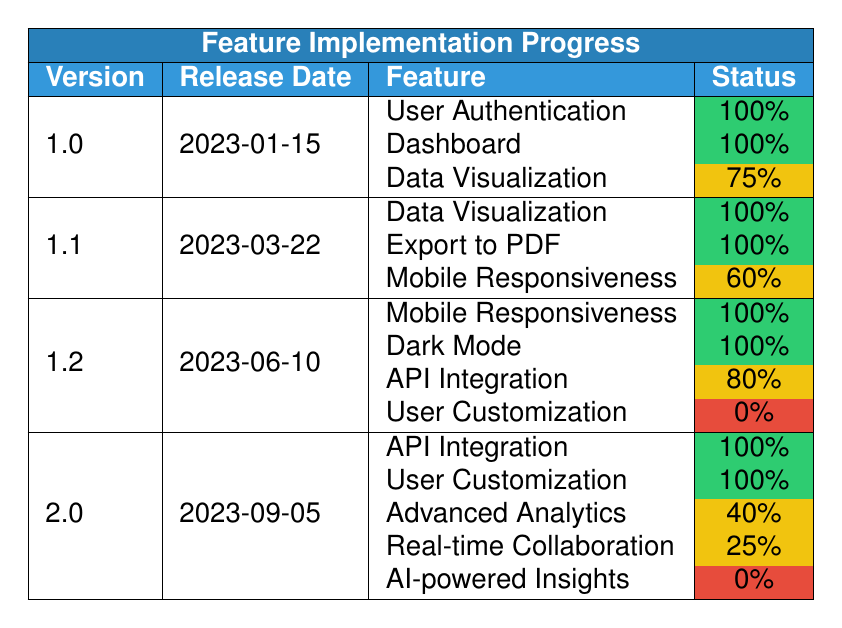What features were completed in version 1.1? In version 1.1, the features listed are Data Visualization (100%), Export to PDF (100%), and Mobile Responsiveness (60%). The completed features are Data Visualization and Export to PDF.
Answer: Data Visualization, Export to PDF What is the completion percentage of the feature "Advanced Analytics" in version 2.0? The feature "Advanced Analytics" in version 2.0 has a completion percentage of 40%, as indicated in the table under the respective version.
Answer: 40% How many features are listed for version 1.2? In version 1.2, there are four features listed: Mobile Responsiveness, Dark Mode, API Integration, and User Customization. Therefore, the total number of features is 4.
Answer: 4 Which version has the latest release date? Version 2.0 has the latest release date of 2023-09-05, compared to the other versions released before this date.
Answer: 2.0 Is the feature "Real-time Collaboration" completed in version 2.0? The feature "Real-time Collaboration" in version 2.0 has a completion status of "In Progress" with a percentage of 25%, indicating it is not completed.
Answer: No What is the average completion percentage of features in version 1.0? The features in version 1.0 are User Authentication (100%), Dashboard (100%), and Data Visualization (75%). The average is calculated as (100 + 100 + 75) / 3 = 91.67.
Answer: 91.67 Which features remain not started across all versions? The features that are not started include User Customization in version 1.2 and AI-powered Insights in version 2.0. Thus, there are two features with this status across all versions.
Answer: 2 What is the overall trend of feature completion status from version 1.0 to version 2.0? By comparing the completion statuses, we see that earlier versions had several features completed while later versions introduced new features like Advanced Analytics and AI-powered Insights, which are either in progress or not started, indicating a mix of completed and ongoing development.
Answer: Mixed progress How many features were completed in version 2.0? In version 2.0, two features are marked as completed: API Integration and User Customization. Thus, the total is 2.
Answer: 2 What percentage of features are still in progress or not started in the latest version 2.0? In version 2.0, three features are listed: Advanced Analytics (40% In Progress), Real-time Collaboration (25% In Progress), and AI-powered Insights (0% Not Started). This totals to 3 features, which means 3 out of 5 are either in progress or not started, resulting in 60%.
Answer: 60% 